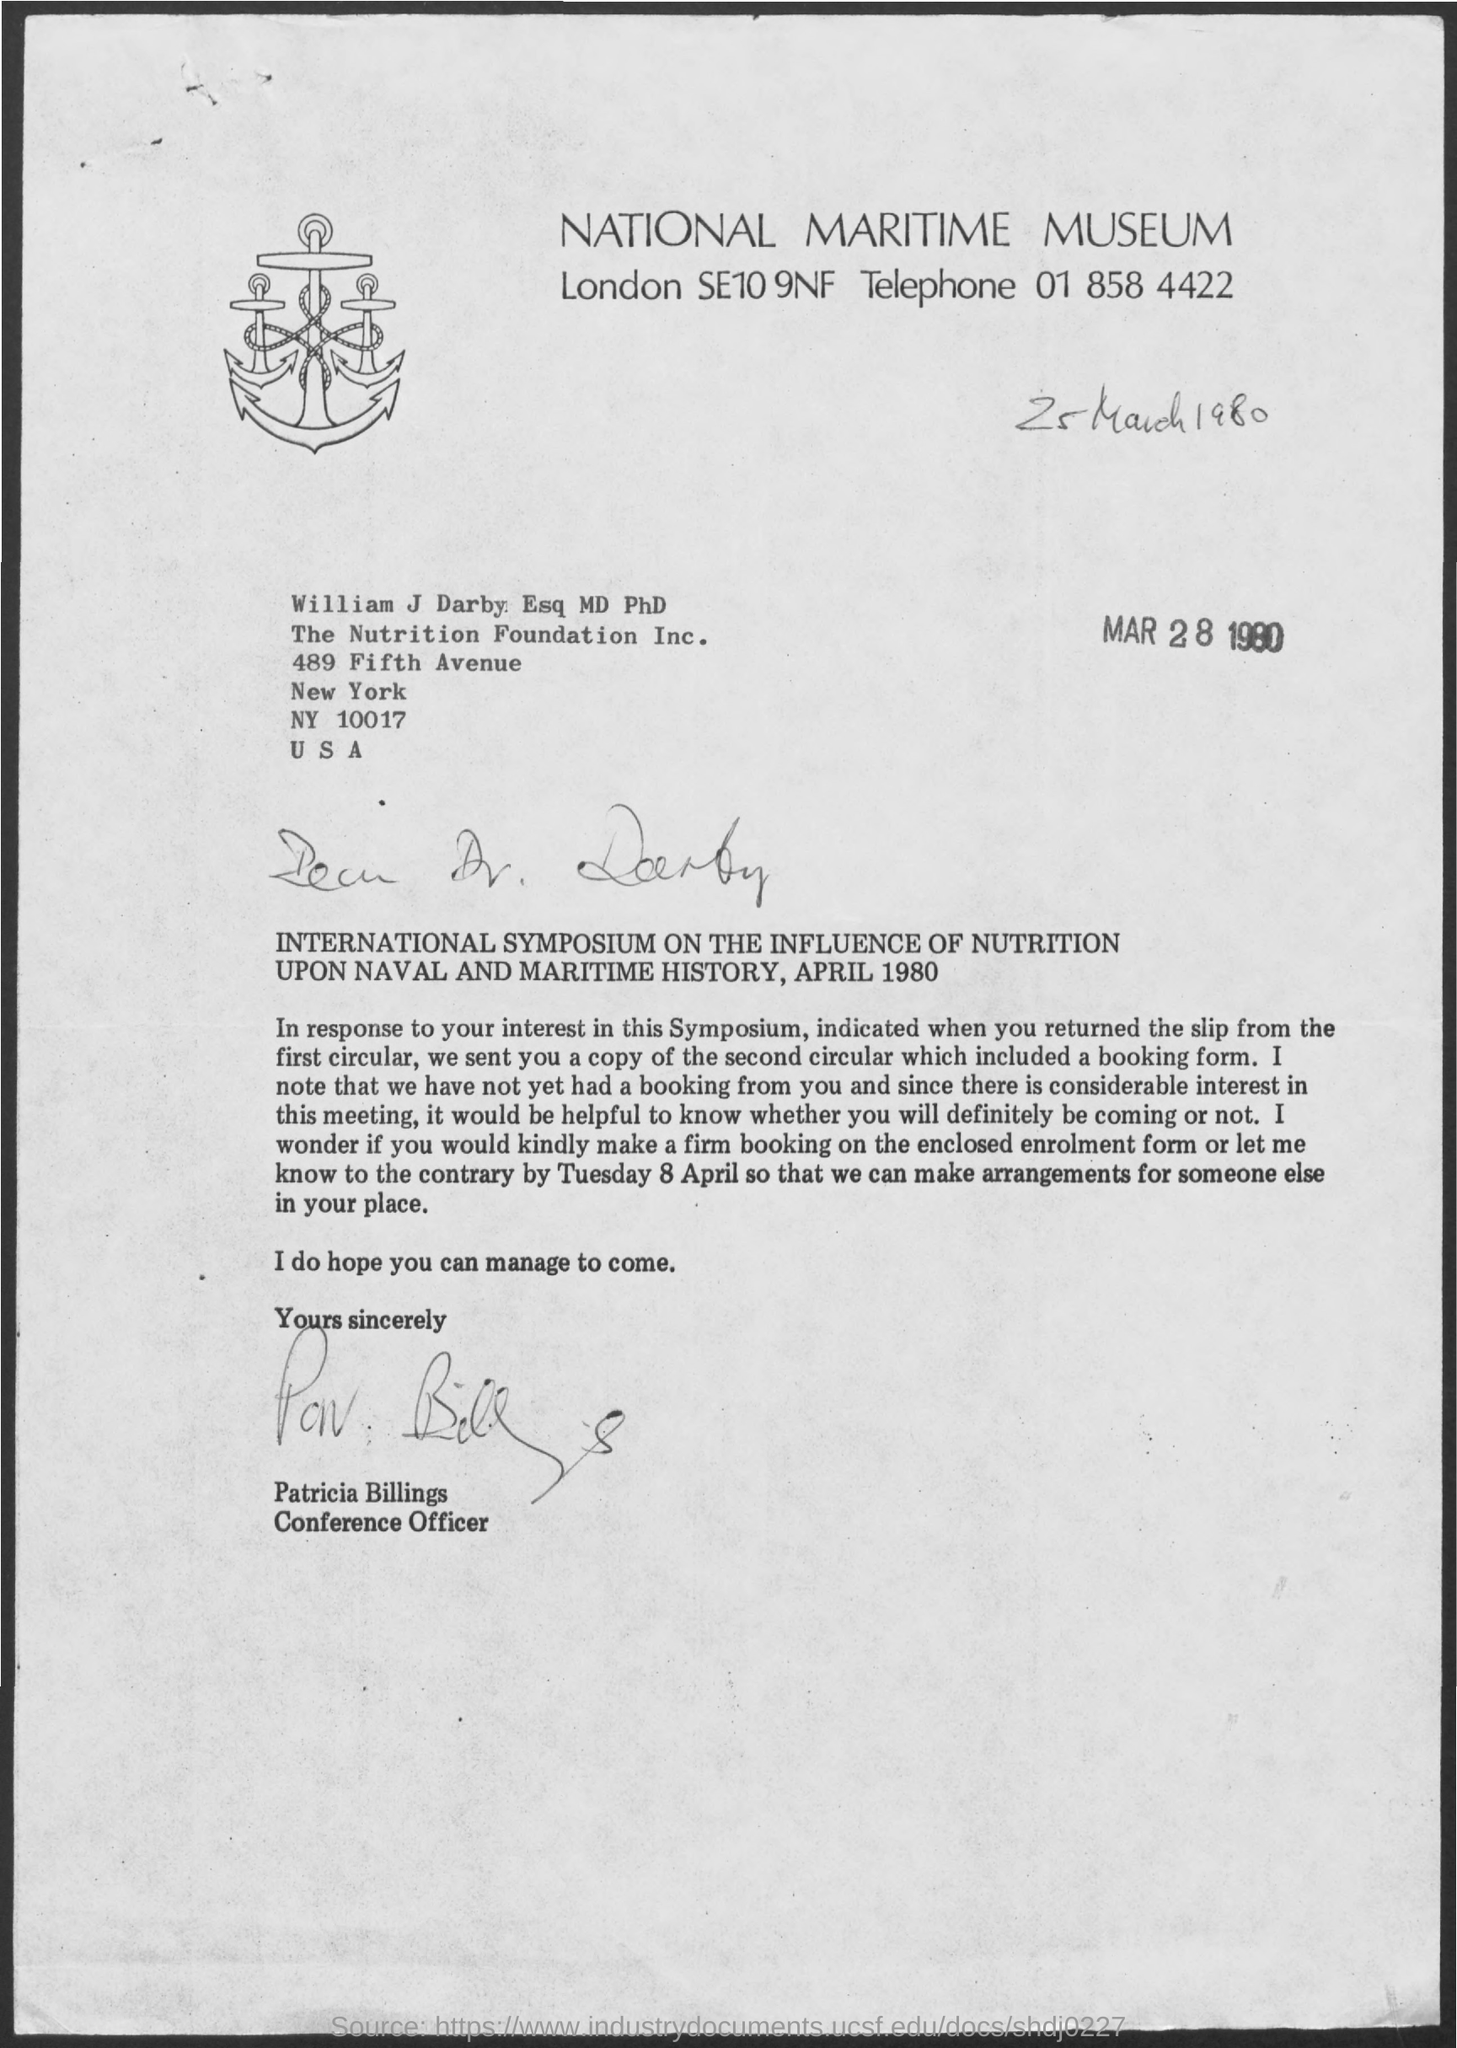Specify some key components in this picture. The letter is from Patricia Billings. The telephone is a device that enables communication by transmitting voice and/or text messages through electromagnetic waves. 